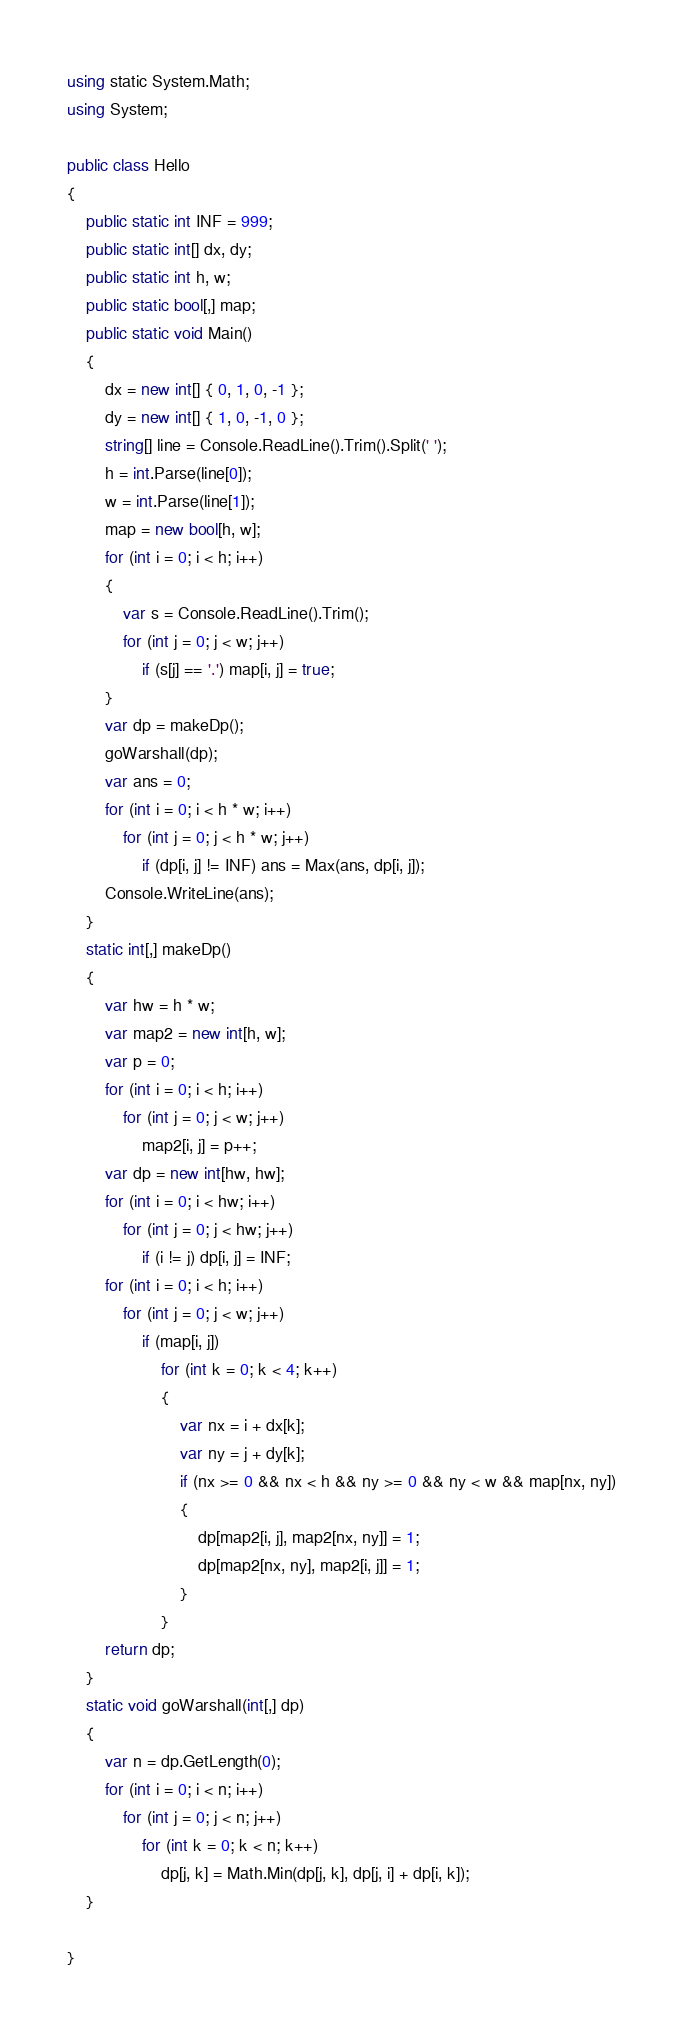Convert code to text. <code><loc_0><loc_0><loc_500><loc_500><_C#_>using static System.Math;
using System;

public class Hello
{
    public static int INF = 999;
    public static int[] dx, dy;
    public static int h, w;
    public static bool[,] map;
    public static void Main()
    {
        dx = new int[] { 0, 1, 0, -1 };
        dy = new int[] { 1, 0, -1, 0 };
        string[] line = Console.ReadLine().Trim().Split(' ');
        h = int.Parse(line[0]);
        w = int.Parse(line[1]);
        map = new bool[h, w];
        for (int i = 0; i < h; i++)
        {
            var s = Console.ReadLine().Trim();
            for (int j = 0; j < w; j++)
                if (s[j] == '.') map[i, j] = true;
        }
        var dp = makeDp();
        goWarshall(dp);
        var ans = 0;
        for (int i = 0; i < h * w; i++)
            for (int j = 0; j < h * w; j++)
                if (dp[i, j] != INF) ans = Max(ans, dp[i, j]);
        Console.WriteLine(ans);
    }
    static int[,] makeDp()
    {
        var hw = h * w;
        var map2 = new int[h, w];
        var p = 0;
        for (int i = 0; i < h; i++)
            for (int j = 0; j < w; j++)
                map2[i, j] = p++;
        var dp = new int[hw, hw];
        for (int i = 0; i < hw; i++)
            for (int j = 0; j < hw; j++)
                if (i != j) dp[i, j] = INF;
        for (int i = 0; i < h; i++)
            for (int j = 0; j < w; j++)
                if (map[i, j])
                    for (int k = 0; k < 4; k++)
                    {
                        var nx = i + dx[k];
                        var ny = j + dy[k];
                        if (nx >= 0 && nx < h && ny >= 0 && ny < w && map[nx, ny])
                        {
                            dp[map2[i, j], map2[nx, ny]] = 1;
                            dp[map2[nx, ny], map2[i, j]] = 1;
                        }
                    }
        return dp;
    }
    static void goWarshall(int[,] dp)
    {
        var n = dp.GetLength(0);
        for (int i = 0; i < n; i++)
            for (int j = 0; j < n; j++)
                for (int k = 0; k < n; k++)
                    dp[j, k] = Math.Min(dp[j, k], dp[j, i] + dp[i, k]);
    }

}
</code> 